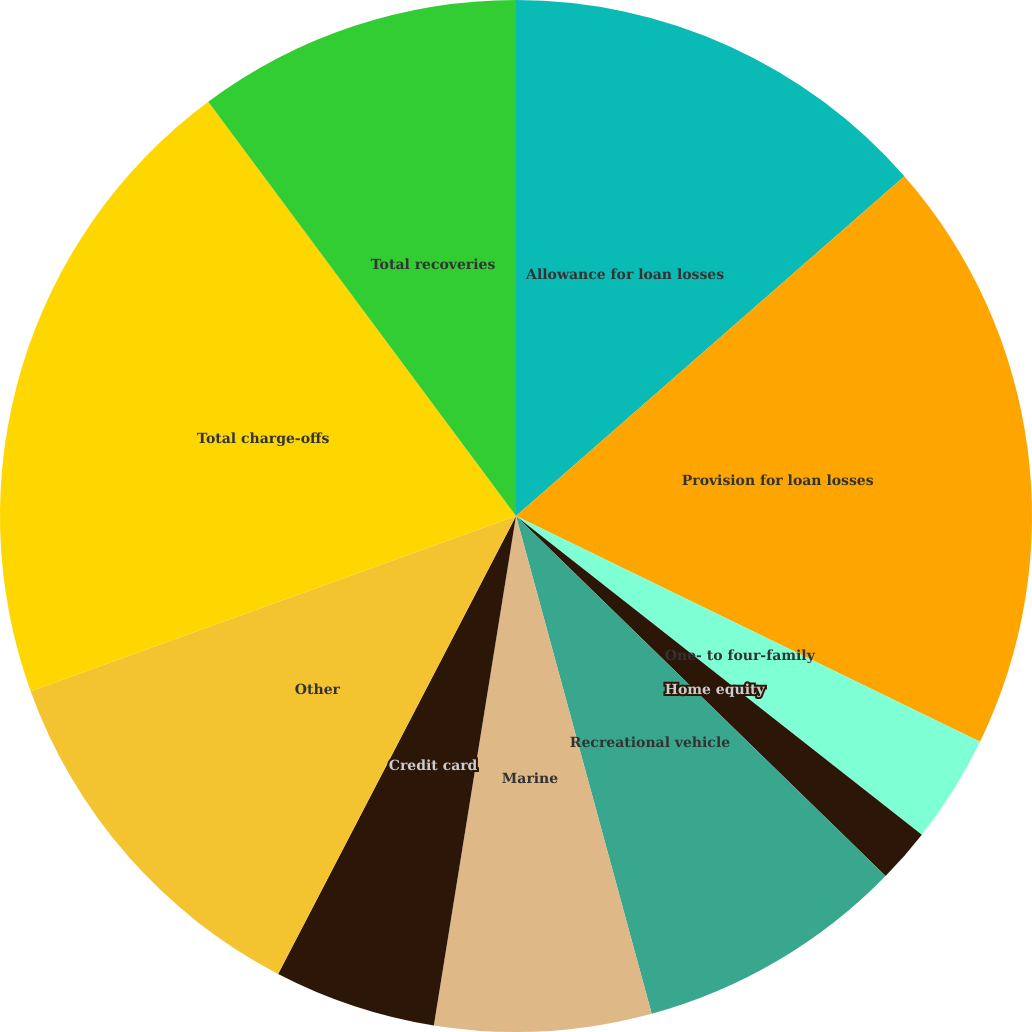Convert chart to OTSL. <chart><loc_0><loc_0><loc_500><loc_500><pie_chart><fcel>Allowance for loan losses<fcel>Provision for loan losses<fcel>One- to four-family<fcel>Home equity<fcel>Recreational vehicle<fcel>Marine<fcel>Credit card<fcel>Other<fcel>Total charge-offs<fcel>Total recoveries<nl><fcel>13.56%<fcel>18.64%<fcel>3.39%<fcel>1.7%<fcel>8.47%<fcel>6.78%<fcel>5.08%<fcel>11.86%<fcel>20.34%<fcel>10.17%<nl></chart> 